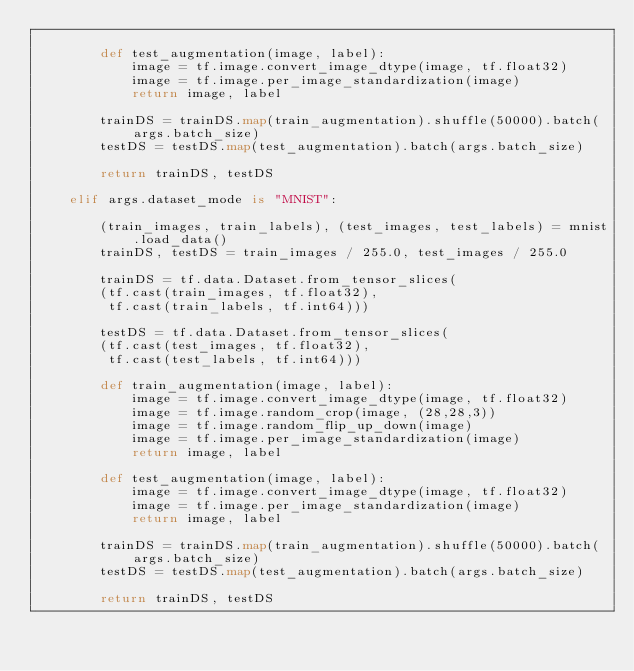Convert code to text. <code><loc_0><loc_0><loc_500><loc_500><_Python_>
        def test_augmentation(image, label):
            image = tf.image.convert_image_dtype(image, tf.float32)
            image = tf.image.per_image_standardization(image)
            return image, label
        
        trainDS = trainDS.map(train_augmentation).shuffle(50000).batch(args.batch_size)
        testDS = testDS.map(test_augmentation).batch(args.batch_size)
        
        return trainDS, testDS

    elif args.dataset_mode is "MNIST":

        (train_images, train_labels), (test_images, test_labels) = mnist.load_data()
        trainDS, testDS = train_images / 255.0, test_images / 255.0
        
        trainDS = tf.data.Dataset.from_tensor_slices(
        (tf.cast(train_images, tf.float32),
         tf.cast(train_labels, tf.int64)))

        testDS = tf.data.Dataset.from_tensor_slices(
        (tf.cast(test_images, tf.float32),
         tf.cast(test_labels, tf.int64)))
        
        def train_augmentation(image, label):
            image = tf.image.convert_image_dtype(image, tf.float32)
            image = tf.image.random_crop(image, (28,28,3))
            image = tf.image.random_flip_up_down(image)
            image = tf.image.per_image_standardization(image)
            return image, label

        def test_augmentation(image, label):
            image = tf.image.convert_image_dtype(image, tf.float32)
            image = tf.image.per_image_standardization(image)
            return image, label
        
        trainDS = trainDS.map(train_augmentation).shuffle(50000).batch(args.batch_size)
        testDS = testDS.map(test_augmentation).batch(args.batch_size)
        
        return trainDS, testDS</code> 